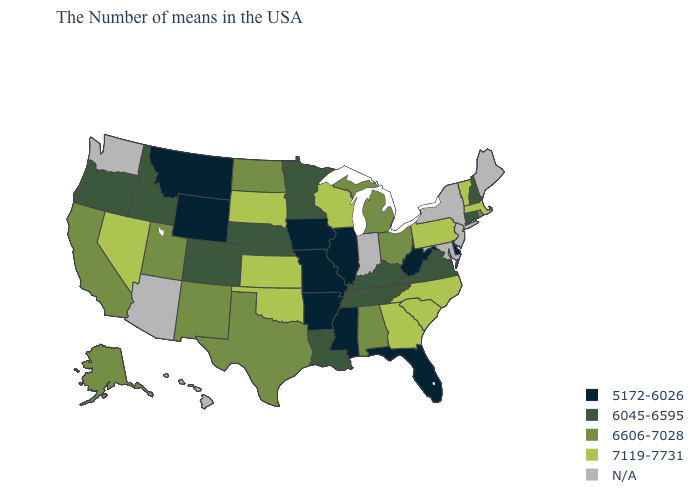What is the value of Georgia?
Write a very short answer. 7119-7731. Among the states that border Nebraska , which have the highest value?
Keep it brief. Kansas, South Dakota. What is the value of Oklahoma?
Write a very short answer. 7119-7731. What is the highest value in states that border Pennsylvania?
Keep it brief. 6606-7028. What is the value of South Carolina?
Keep it brief. 7119-7731. What is the value of New Hampshire?
Keep it brief. 6045-6595. What is the lowest value in the USA?
Be succinct. 5172-6026. What is the value of New Mexico?
Be succinct. 6606-7028. Name the states that have a value in the range 6606-7028?
Quick response, please. Rhode Island, Ohio, Michigan, Alabama, Texas, North Dakota, New Mexico, Utah, California, Alaska. What is the highest value in the USA?
Keep it brief. 7119-7731. Among the states that border Arizona , does Nevada have the highest value?
Write a very short answer. Yes. What is the highest value in the South ?
Answer briefly. 7119-7731. Name the states that have a value in the range 5172-6026?
Write a very short answer. Delaware, West Virginia, Florida, Illinois, Mississippi, Missouri, Arkansas, Iowa, Wyoming, Montana. Name the states that have a value in the range 6045-6595?
Concise answer only. New Hampshire, Connecticut, Virginia, Kentucky, Tennessee, Louisiana, Minnesota, Nebraska, Colorado, Idaho, Oregon. What is the lowest value in the USA?
Answer briefly. 5172-6026. 